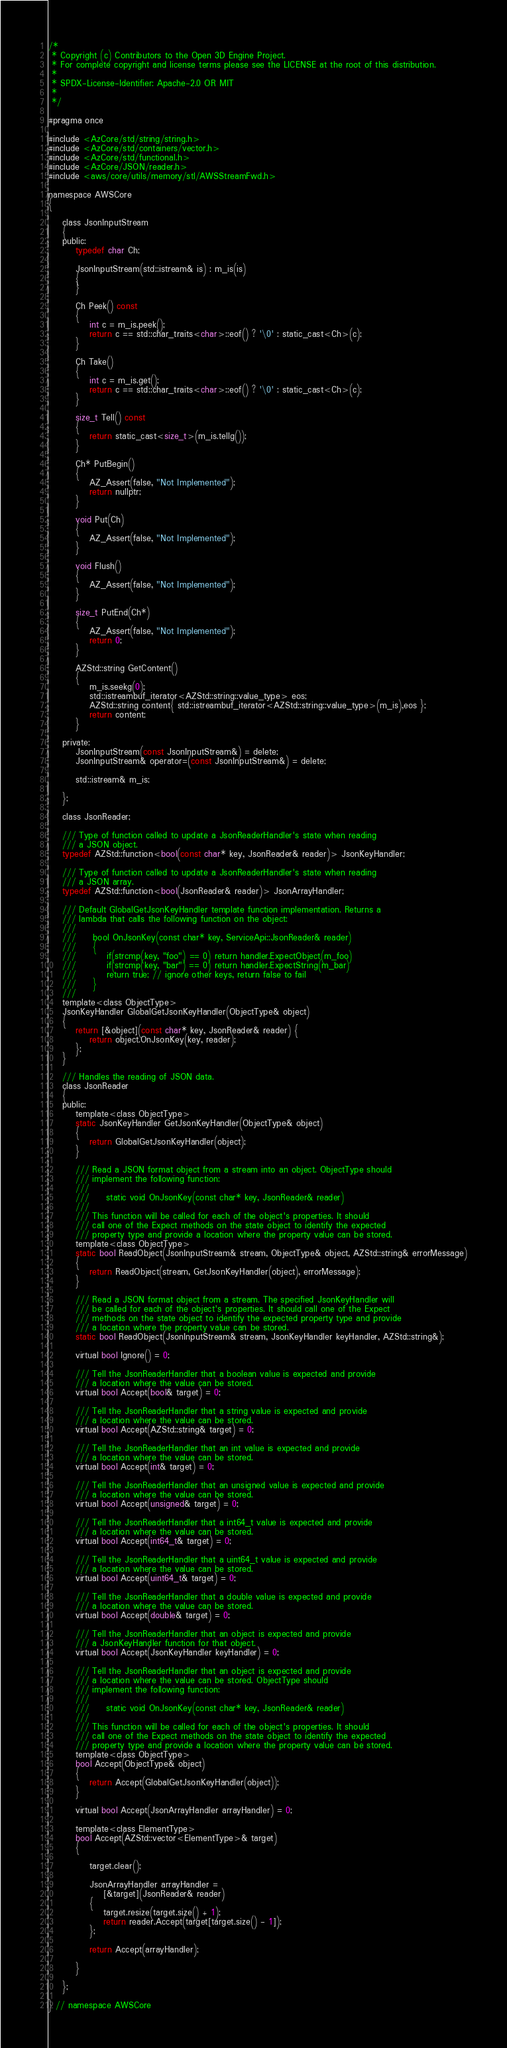Convert code to text. <code><loc_0><loc_0><loc_500><loc_500><_C_>/*
 * Copyright (c) Contributors to the Open 3D Engine Project.
 * For complete copyright and license terms please see the LICENSE at the root of this distribution.
 *
 * SPDX-License-Identifier: Apache-2.0 OR MIT
 *
 */

#pragma once

#include <AzCore/std/string/string.h>
#include <AzCore/std/containers/vector.h>
#include <AzCore/std/functional.h>
#include <AzCore/JSON/reader.h>
#include <aws/core/utils/memory/stl/AWSStreamFwd.h>

namespace AWSCore
{

    class JsonInputStream
    {
    public:
        typedef char Ch;

        JsonInputStream(std::istream& is) : m_is(is)
        {
        }

        Ch Peek() const
        {
            int c = m_is.peek();
            return c == std::char_traits<char>::eof() ? '\0' : static_cast<Ch>(c);
        }

        Ch Take()
        {
            int c = m_is.get();
            return c == std::char_traits<char>::eof() ? '\0' : static_cast<Ch>(c);
        }

        size_t Tell() const
        {
            return static_cast<size_t>(m_is.tellg());
        }

        Ch* PutBegin()
        {
            AZ_Assert(false, "Not Implemented");
            return nullptr;
        }

        void Put(Ch)
        {
            AZ_Assert(false, "Not Implemented");
        }

        void Flush()
        {
            AZ_Assert(false, "Not Implemented");
        }

        size_t PutEnd(Ch*)
        {
            AZ_Assert(false, "Not Implemented");
            return 0;
        }

        AZStd::string GetContent()
        {
            m_is.seekg(0);
            std::istreambuf_iterator<AZStd::string::value_type> eos;
            AZStd::string content{ std::istreambuf_iterator<AZStd::string::value_type>(m_is),eos };
            return content;
        }

    private:
        JsonInputStream(const JsonInputStream&) = delete;
        JsonInputStream& operator=(const JsonInputStream&) = delete;

        std::istream& m_is;

    };

    class JsonReader;

    /// Type of function called to update a JsonReaderHandler's state when reading 
    /// a JSON object.
    typedef AZStd::function<bool(const char* key, JsonReader& reader)> JsonKeyHandler;

    /// Type of function called to update a JsonReaderHandler's state when reading 
    /// a JSON array.
    typedef AZStd::function<bool(JsonReader& reader)> JsonArrayHandler;

    /// Default GlobalGetJsonKeyHandler template function implementation. Returns a 
    /// lambda that calls the following function on the object:
    ///
    ///     bool OnJsonKey(const char* key, ServiceApi::JsonReader& reader)
    ///     {
    ///         if(strcmp(key, "foo") == 0) return handler.ExpectObject(m_foo)
    ///         if(strcmp(key, "bar") == 0) return handler.ExpectString(m_bar)
    ///         return true; // ignore other keys, return false to fail
    ///     }
    ///
    template<class ObjectType>
    JsonKeyHandler GlobalGetJsonKeyHandler(ObjectType& object)
    {
        return [&object](const char* key, JsonReader& reader) {
            return object.OnJsonKey(key, reader);
        };
    }

    /// Handles the reading of JSON data.
    class JsonReader
    {
    public:
        template<class ObjectType>
        static JsonKeyHandler GetJsonKeyHandler(ObjectType& object)
        {
            return GlobalGetJsonKeyHandler(object);
        }

        /// Read a JSON format object from a stream into an object. ObjectType should
        /// implement the following function:
        ///
        ///     static void OnJsonKey(const char* key, JsonReader& reader)
        ///
        /// This function will be called for each of the object's properties. It should 
        /// call one of the Expect methods on the state object to identify the expected
        /// property type and provide a location where the property value can be stored.
        template<class ObjectType>
        static bool ReadObject(JsonInputStream& stream, ObjectType& object, AZStd::string& errorMessage)
        {
            return ReadObject(stream, GetJsonKeyHandler(object), errorMessage);
        }

        /// Read a JSON format object from a stream. The specified JsonKeyHandler will
        /// be called for each of the object's properties. It should call one of the Expect
        /// methods on the state object to identify the expected property type and provide
        /// a location where the property value can be stored.
        static bool ReadObject(JsonInputStream& stream, JsonKeyHandler keyHandler, AZStd::string&);

        virtual bool Ignore() = 0;

        /// Tell the JsonReaderHandler that a boolean value is expected and provide 
        /// a location where the value can be stored.
        virtual bool Accept(bool& target) = 0;

        /// Tell the JsonReaderHandler that a string value is expected and provide 
        /// a location where the value can be stored.
        virtual bool Accept(AZStd::string& target) = 0;

        /// Tell the JsonReaderHandler that an int value is expected and provide 
        /// a location where the value can be stored.
        virtual bool Accept(int& target) = 0;

        /// Tell the JsonReaderHandler that an unsigned value is expected and provide 
        /// a location where the value can be stored.
        virtual bool Accept(unsigned& target) = 0;

        /// Tell the JsonReaderHandler that a int64_t value is expected and provide 
        /// a location where the value can be stored.
        virtual bool Accept(int64_t& target) = 0;

        /// Tell the JsonReaderHandler that a uint64_t value is expected and provide 
        /// a location where the value can be stored.
        virtual bool Accept(uint64_t& target) = 0;

        /// Tell the JsonReaderHandler that a double value is expected and provide 
        /// a location where the value can be stored.
        virtual bool Accept(double& target) = 0;

        /// Tell the JsonReaderHandler that an object is expected and provide
        /// a JsonKeyHandler function for that object.
        virtual bool Accept(JsonKeyHandler keyHandler) = 0;

        /// Tell the JsonReaderHandler that an object is expected and provide 
        /// a location where the value can be stored. ObjectType should
        /// implement the following function:
        ///
        ///     static void OnJsonKey(const char* key, JsonReader& reader)
        ///
        /// This function will be called for each of the object's properties. It should 
        /// call one of the Expect methods on the state object to identify the expected
        /// property type and provide a location where the property value can be stored.
        template<class ObjectType>
        bool Accept(ObjectType& object)
        {
            return Accept(GlobalGetJsonKeyHandler(object));
        }

        virtual bool Accept(JsonArrayHandler arrayHandler) = 0;

        template<class ElementType>
        bool Accept(AZStd::vector<ElementType>& target)
        {

            target.clear();

            JsonArrayHandler arrayHandler =
                [&target](JsonReader& reader)
            {
                target.resize(target.size() + 1);
                return reader.Accept(target[target.size() - 1]);
            };

            return Accept(arrayHandler);

        }

    };

} // namespace AWSCore
</code> 